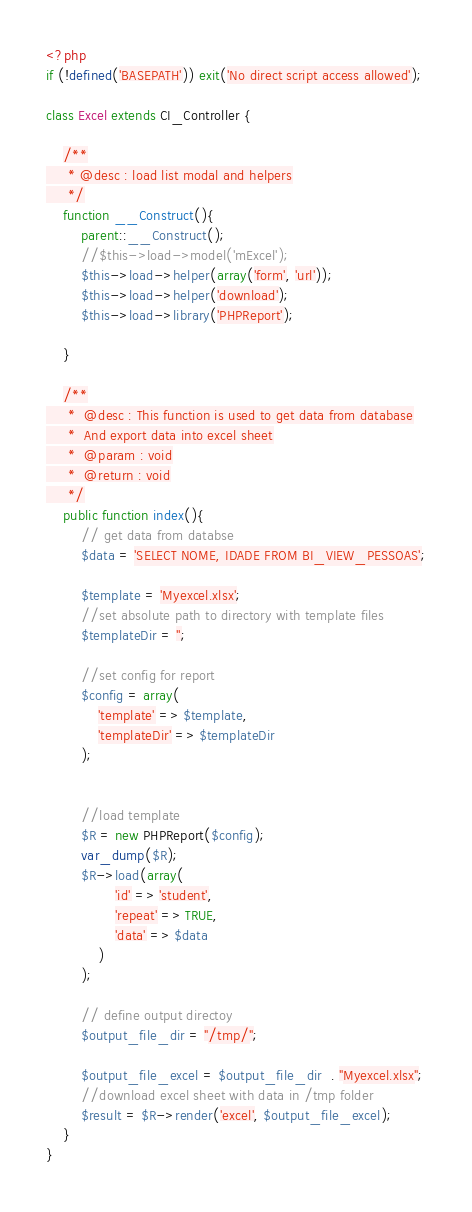Convert code to text. <code><loc_0><loc_0><loc_500><loc_500><_PHP_><?php
if (!defined('BASEPATH')) exit('No direct script access allowed');

class Excel extends CI_Controller {

    /**
     * @desc : load list modal and helpers
     */
    function __Construct(){
        parent::__Construct();
        //$this->load->model('mExcel');
        $this->load->helper(array('form', 'url'));
        $this->load->helper('download');
        $this->load->library('PHPReport');

    }

    /**
     *  @desc : This function is used to get data from database
     *  And export data into excel sheet
     *  @param : void
     *  @return : void
     */
    public function index(){
        // get data from databse
        $data = 'SELECT NOME, IDADE FROM BI_VIEW_PESSOAS';

        $template = 'Myexcel.xlsx';
        //set absolute path to directory with template files
        $templateDir = '';

        //set config for report
        $config = array(
            'template' => $template,
            'templateDir' => $templateDir
        );


        //load template
        $R = new PHPReport($config);
        var_dump($R);
        $R->load(array(
                'id' => 'student',
                'repeat' => TRUE,
                'data' => $data
            )
        );

        // define output directoy
        $output_file_dir = "/tmp/";

        $output_file_excel = $output_file_dir  . "Myexcel.xlsx";
        //download excel sheet with data in /tmp folder
        $result = $R->render('excel', $output_file_excel);
    }
}</code> 